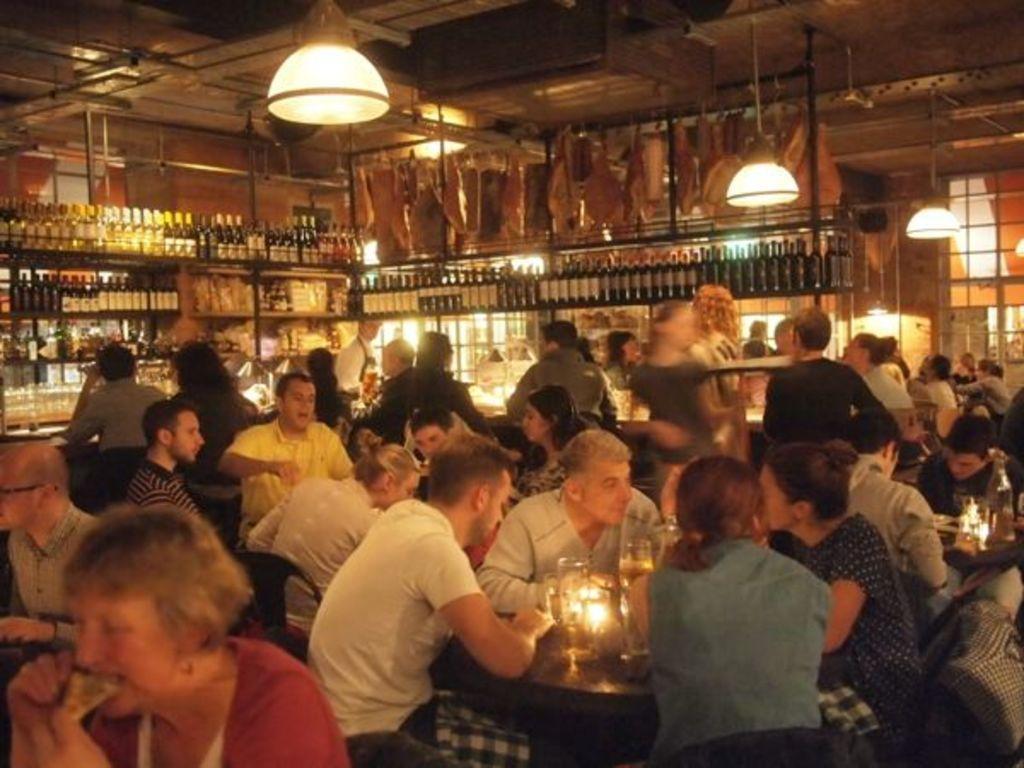Please provide a concise description of this image. In the picture I can see these people are sitting on the chairs near the table where glasses, candles and few more objects are placed on the table. In the background, we can see a few people are standing, we can see many bottles are kept on the shelves and we can see the ceiling lights. 